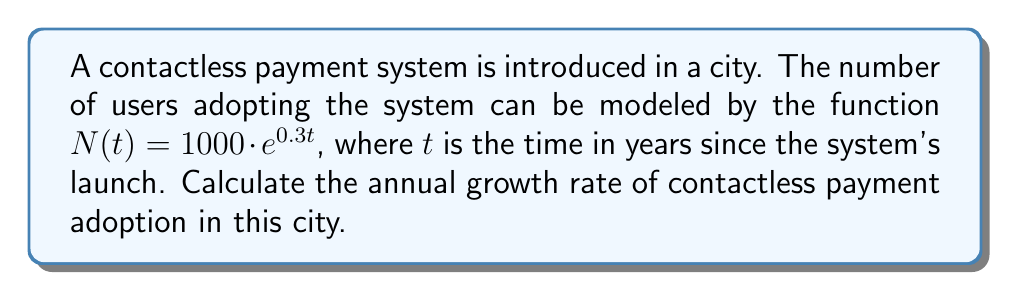Solve this math problem. To calculate the annual growth rate, we need to follow these steps:

1) The general form of an exponential growth function is:
   $N(t) = N_0 \cdot e^{rt}$
   where $N_0$ is the initial value, $r$ is the continuous growth rate, and $t$ is time.

2) In our case, $N(t) = 1000 \cdot e^{0.3t}$
   So, $N_0 = 1000$ and $r = 0.3$

3) The continuous growth rate $r$ is related to the annual growth rate $g$ by the formula:
   $g = e^r - 1$

4) Substituting our $r$ value:
   $g = e^{0.3} - 1$

5) Calculate:
   $g = 1.3498588075760032... - 1$
   $g = 0.3498588075760032...$

6) Convert to percentage:
   $g \approx 34.99\%$

Therefore, the annual growth rate is approximately 34.99%.
Answer: 34.99% 